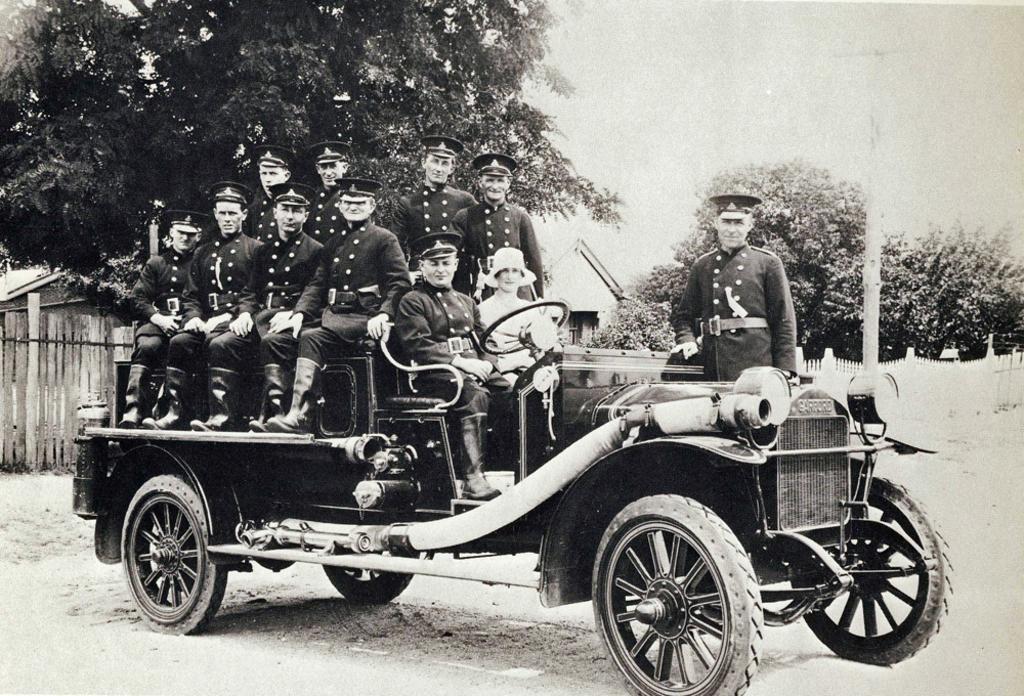Could you give a brief overview of what you see in this image? In this picture I can see there is a car and some people are sitting in the car and there is a person standing here. In the backdrop there is a wall, building and trees and the sky is clear. 